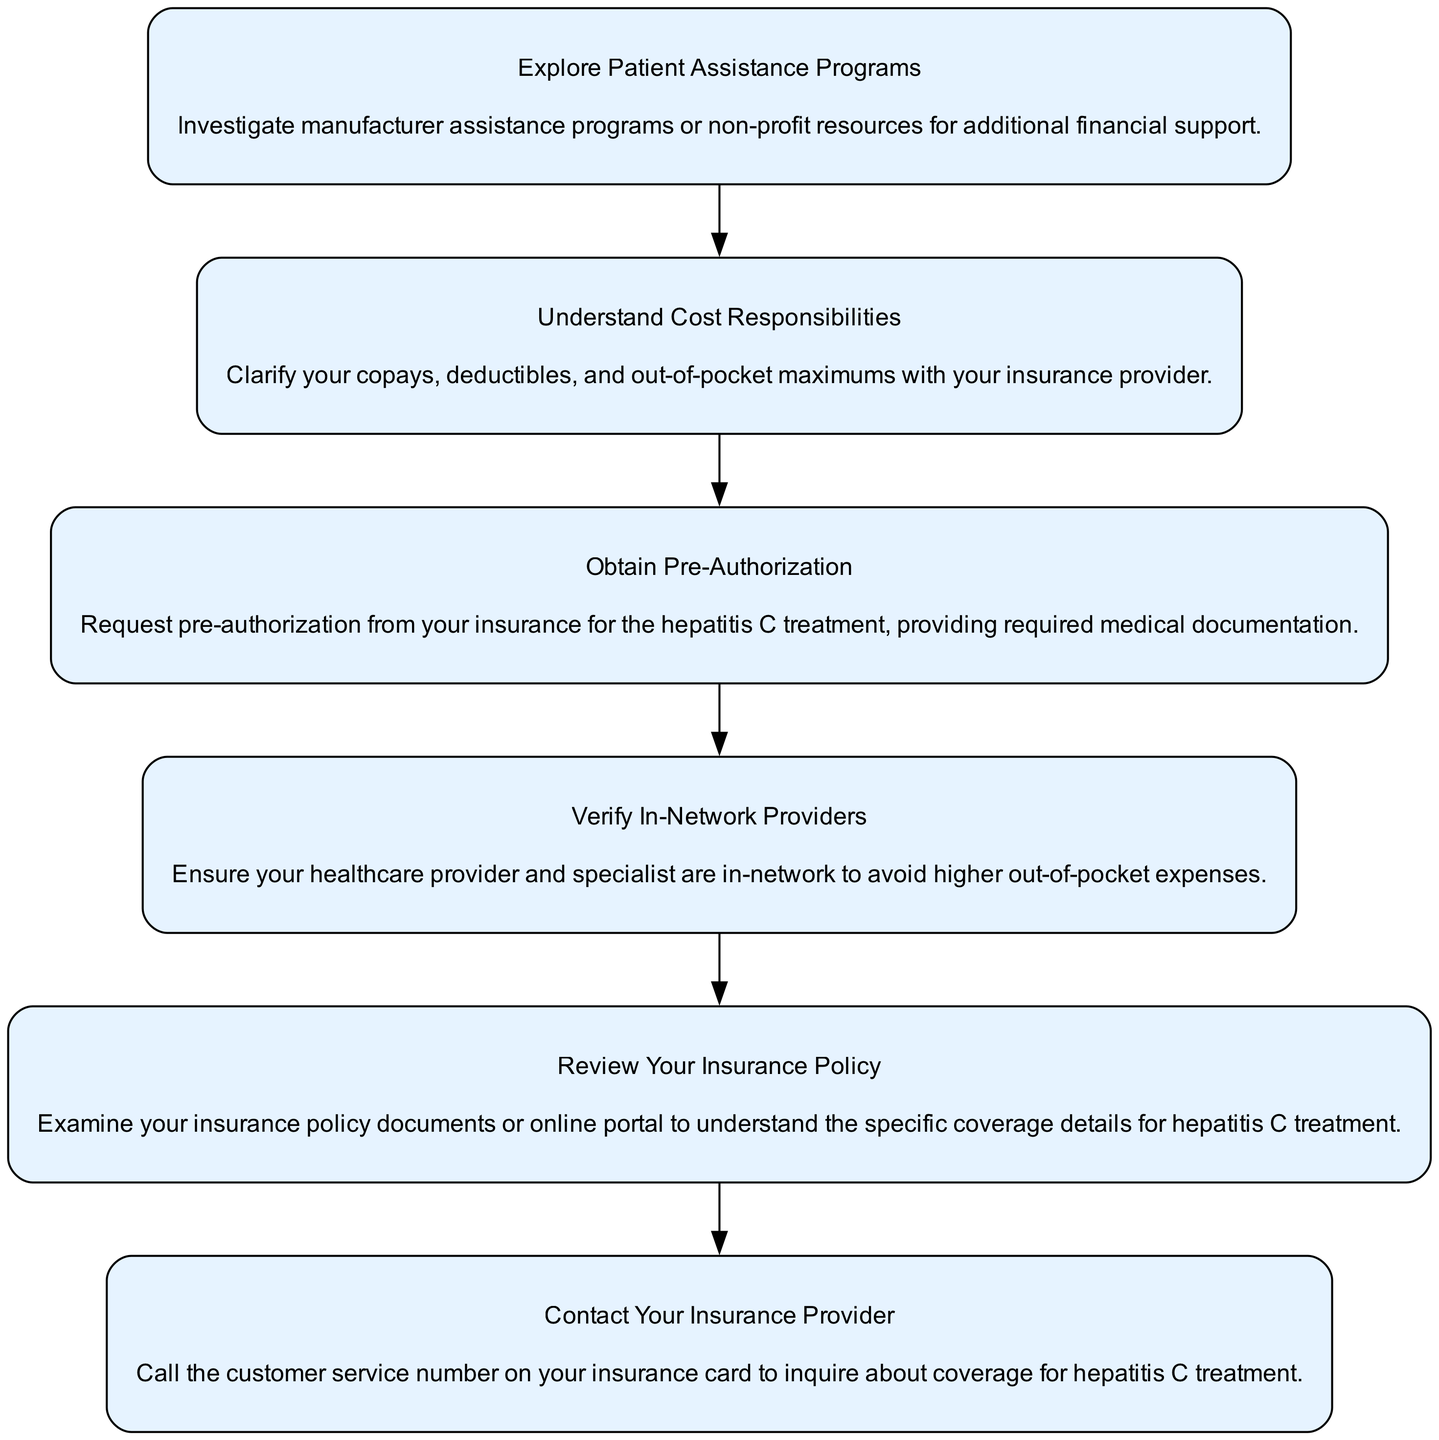What is the first step in the flow chart? The flow chart begins with "Contact Your Insurance Provider," which is stated in the first node. This node outlines the initial action one should take regarding their hepatitis C treatment coverage.
Answer: Contact Your Insurance Provider How many total steps are depicted in the diagram? There are six distinct nodes in the flow chart, each representing a step to navigate health insurance coverage for hepatitis C treatment. Counting all of them confirms the total.
Answer: Six What must you obtain before starting hepatitis C treatment? According to the diagram, you need to "Obtain Pre-Authorization," which is outlined as a crucial step in the process necessary before treatment can begin.
Answer: Obtain Pre-Authorization Which step follows reviewing your insurance policy? After "Review Your Insurance Policy," the next step in the flow chart is "Verify In-Network Providers," which is indicated by a direct edge leading from the second to the third node.
Answer: Verify In-Network Providers What does understanding cost responsibilities involve? "Understand Cost Responsibilities" involves clarifying your copays, deductibles, and out-of-pocket maximums as detailed in the corresponding node of the flow chart. This is critical for managing financial expectations before treatment.
Answer: Clarifying copays, deductibles, and out-of-pocket maximums What is the unique contribution of patient assistance programs in this context? The "Explore Patient Assistance Programs" step represents an additional resource to seek financial support, reflecting the flow chart's emphasis on exploring various options to alleviate treatment costs.
Answer: Additional financial support Is there a step for verifying healthcare provider networks? Yes, the flow chart includes "Verify In-Network Providers," which addresses the need to confirm if your healthcare provider is part of your insurance network to manage costs effectively.
Answer: Yes What is the purpose of contacting your insurance provider? The purpose of "Contact Your Insurance Provider" is to inquire specifically about coverage for hepatitis C treatment, as stated in the description provided in the corresponding node.
Answer: Inquire about coverage for hepatitis C treatment 